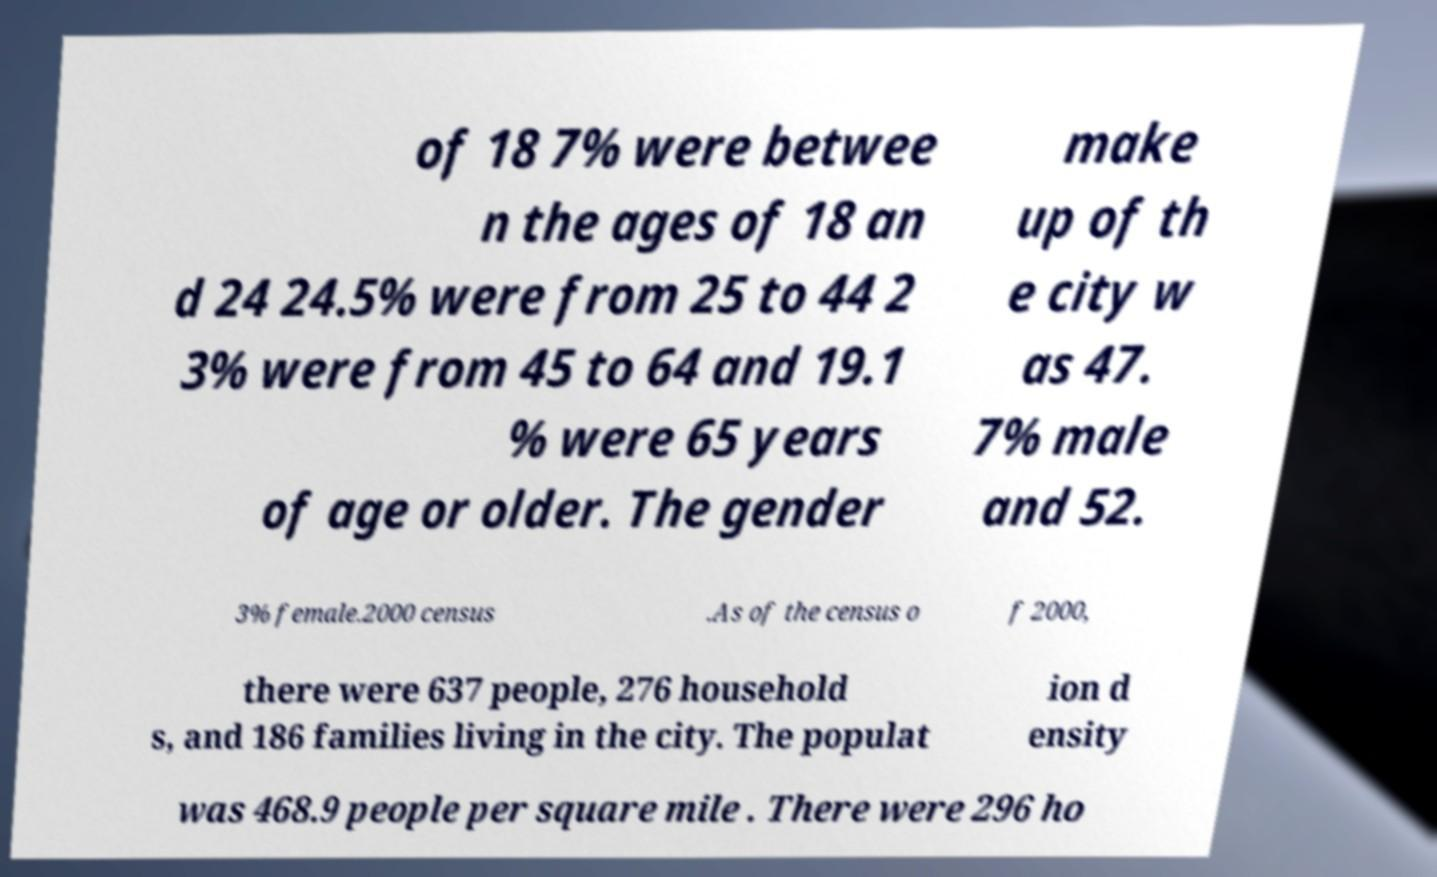What messages or text are displayed in this image? I need them in a readable, typed format. of 18 7% were betwee n the ages of 18 an d 24 24.5% were from 25 to 44 2 3% were from 45 to 64 and 19.1 % were 65 years of age or older. The gender make up of th e city w as 47. 7% male and 52. 3% female.2000 census .As of the census o f 2000, there were 637 people, 276 household s, and 186 families living in the city. The populat ion d ensity was 468.9 people per square mile . There were 296 ho 